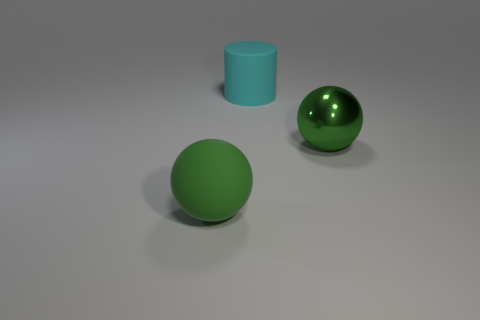How many objects are large things that are to the right of the big rubber ball or objects on the left side of the big cyan rubber cylinder?
Make the answer very short. 3. There is a cyan rubber cylinder; are there any green rubber objects in front of it?
Make the answer very short. Yes. The large sphere behind the green sphere that is left of the green sphere behind the green rubber ball is what color?
Your answer should be very brief. Green. Do the big green shiny object and the green rubber object have the same shape?
Your response must be concise. Yes. What is the color of the large sphere that is the same material as the large cylinder?
Ensure brevity in your answer.  Green. What number of things are large metallic things in front of the big cylinder or big green metal things?
Offer a very short reply. 1. What is the size of the rubber thing that is behind the green matte object?
Make the answer very short. Large. Do the cyan matte thing and the ball to the right of the large green matte sphere have the same size?
Offer a very short reply. Yes. There is a big matte ball that is to the left of the large matte cylinder left of the green metal ball; what is its color?
Your answer should be very brief. Green. What number of other objects are the same color as the matte cylinder?
Your answer should be very brief. 0. 